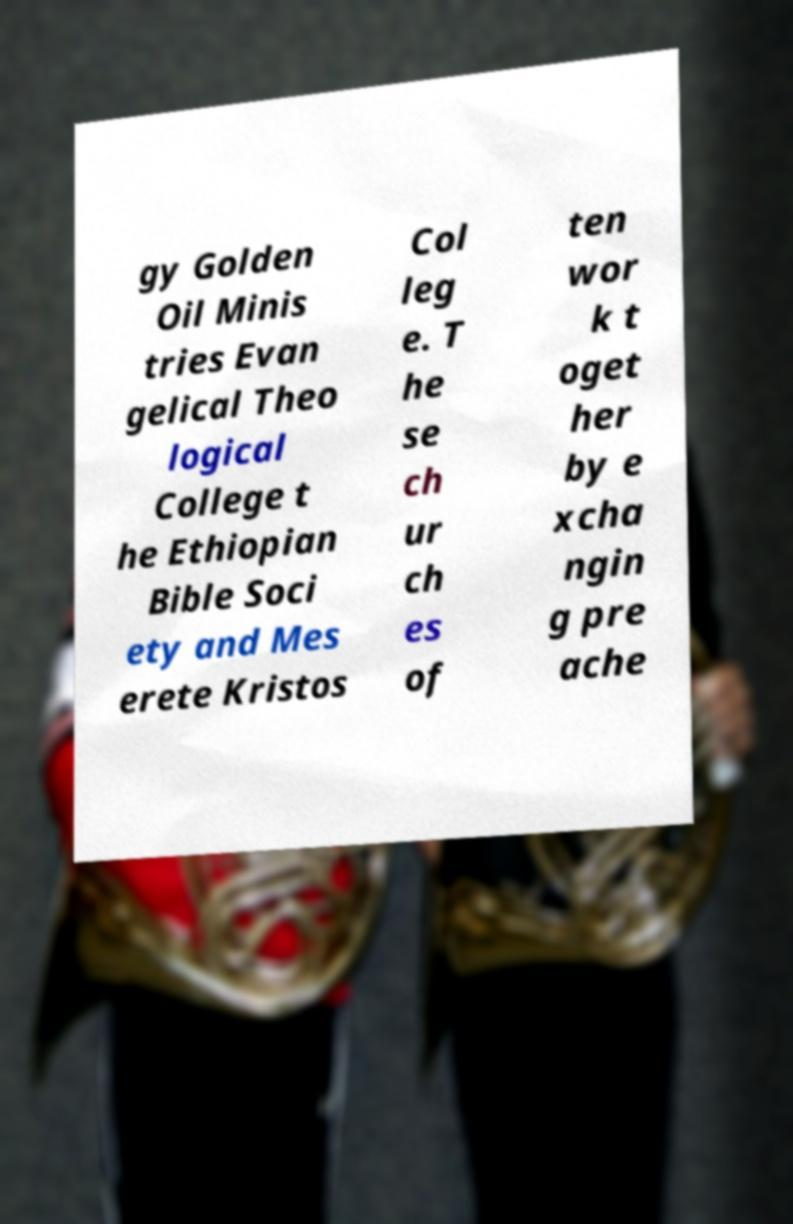What messages or text are displayed in this image? I need them in a readable, typed format. gy Golden Oil Minis tries Evan gelical Theo logical College t he Ethiopian Bible Soci ety and Mes erete Kristos Col leg e. T he se ch ur ch es of ten wor k t oget her by e xcha ngin g pre ache 